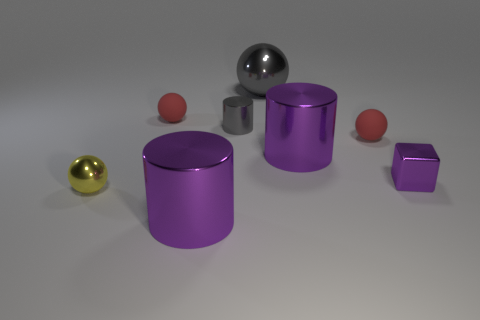What number of large objects have the same material as the small gray thing? There are two large objects that appear to have the same metallic material as the small gray sphere. These are the larger gray sphere and the cylinder with a metallic sheen similar to that of the spheres. 